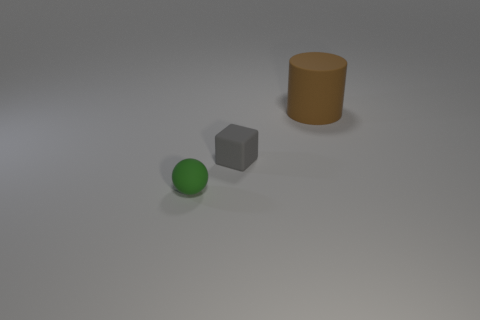Is there any other thing that is the same shape as the large object?
Provide a short and direct response. No. Are any large blue metal cylinders visible?
Provide a short and direct response. No. Does the large matte object have the same shape as the gray rubber object?
Your answer should be very brief. No. How many small objects are either green rubber spheres or red objects?
Keep it short and to the point. 1. The sphere is what color?
Your answer should be compact. Green. The small thing that is behind the rubber object that is in front of the gray rubber block is what shape?
Offer a very short reply. Cube. Is there another tiny gray object that has the same material as the gray object?
Provide a short and direct response. No. There is a rubber object that is right of the gray rubber object; is its size the same as the green thing?
Provide a short and direct response. No. How many gray things are blocks or tiny things?
Offer a terse response. 1. There is a object in front of the gray matte object; what material is it?
Provide a succinct answer. Rubber. 